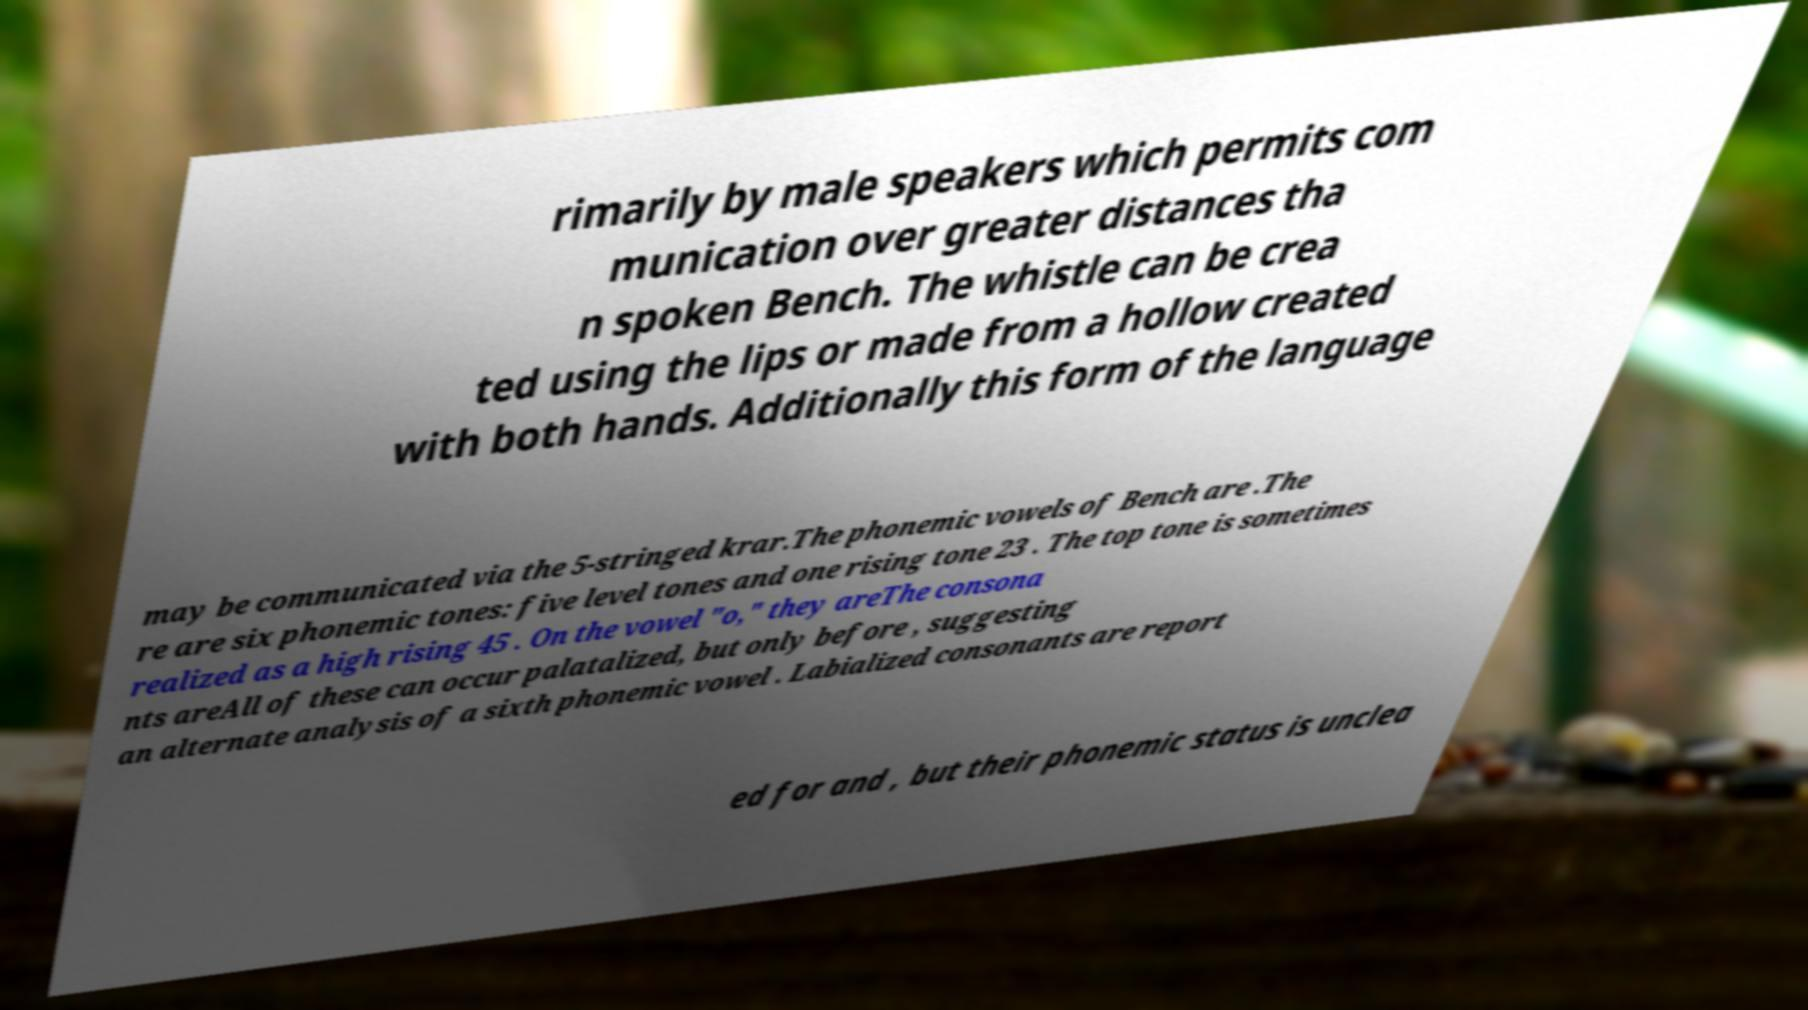There's text embedded in this image that I need extracted. Can you transcribe it verbatim? rimarily by male speakers which permits com munication over greater distances tha n spoken Bench. The whistle can be crea ted using the lips or made from a hollow created with both hands. Additionally this form of the language may be communicated via the 5-stringed krar.The phonemic vowels of Bench are .The re are six phonemic tones: five level tones and one rising tone 23 . The top tone is sometimes realized as a high rising 45 . On the vowel "o," they areThe consona nts areAll of these can occur palatalized, but only before , suggesting an alternate analysis of a sixth phonemic vowel . Labialized consonants are report ed for and , but their phonemic status is unclea 